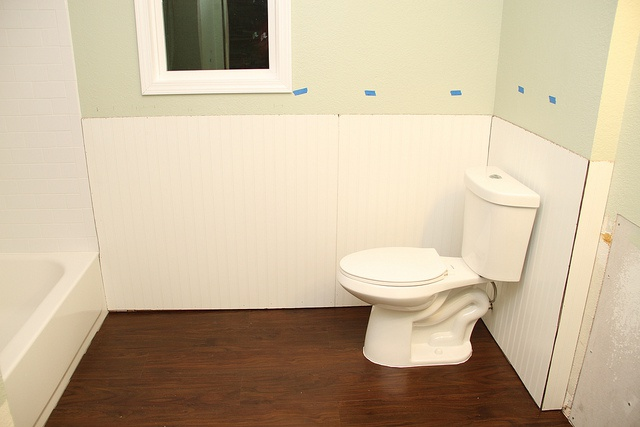Describe the objects in this image and their specific colors. I can see a toilet in tan and beige tones in this image. 